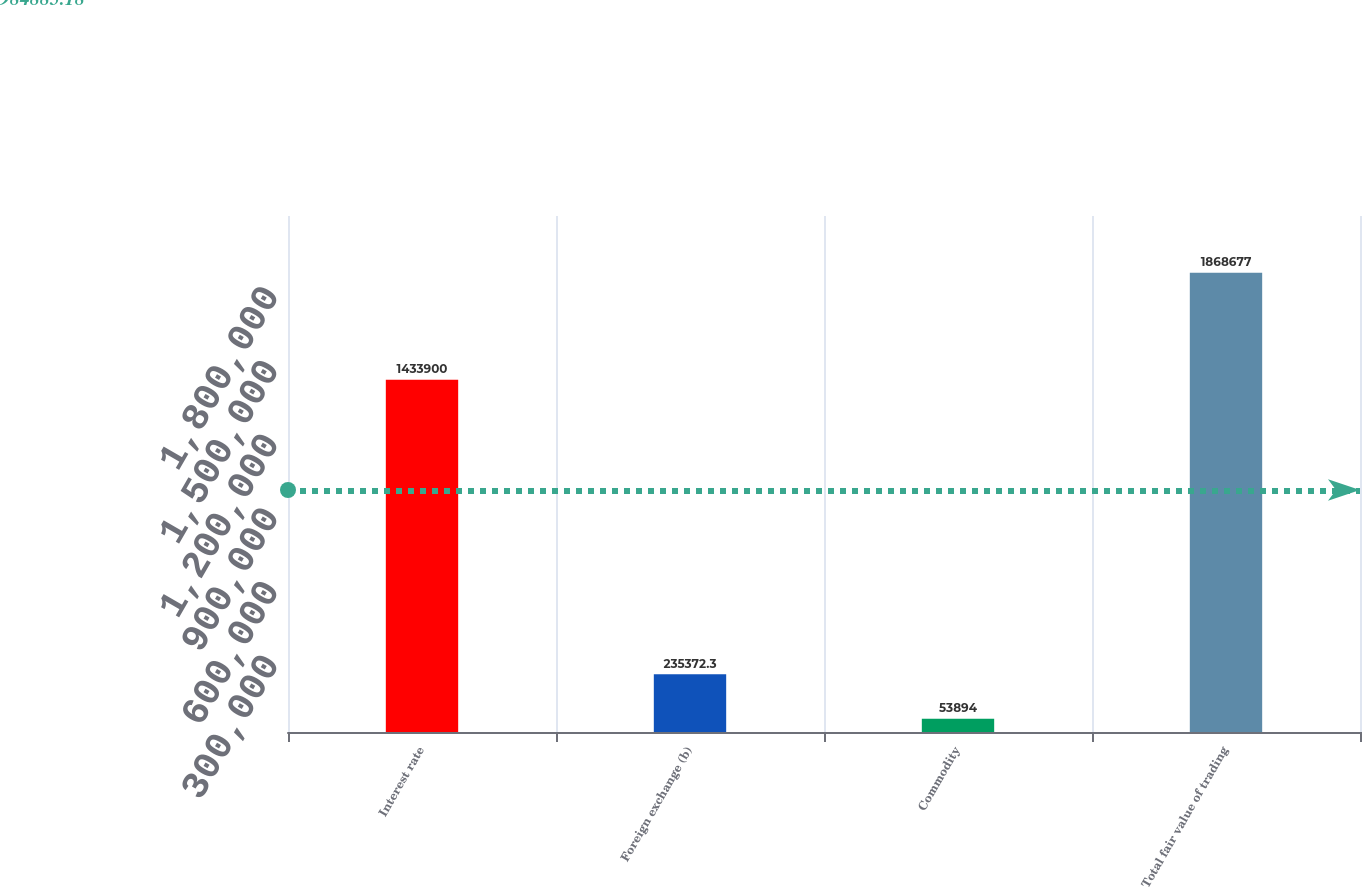<chart> <loc_0><loc_0><loc_500><loc_500><bar_chart><fcel>Interest rate<fcel>Foreign exchange (b)<fcel>Commodity<fcel>Total fair value of trading<nl><fcel>1.4339e+06<fcel>235372<fcel>53894<fcel>1.86868e+06<nl></chart> 